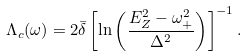<formula> <loc_0><loc_0><loc_500><loc_500>\Lambda _ { c } ( \omega ) = { 2 \bar { \delta } } \left [ \ln \left ( \frac { E _ { Z } ^ { 2 } - \omega ^ { 2 } _ { + } } { \Delta ^ { 2 } } \right ) \right ] ^ { - 1 } .</formula> 